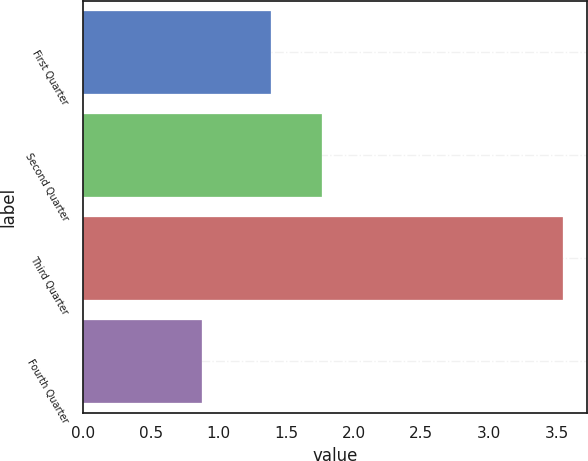Convert chart. <chart><loc_0><loc_0><loc_500><loc_500><bar_chart><fcel>First Quarter<fcel>Second Quarter<fcel>Third Quarter<fcel>Fourth Quarter<nl><fcel>1.39<fcel>1.77<fcel>3.55<fcel>0.88<nl></chart> 